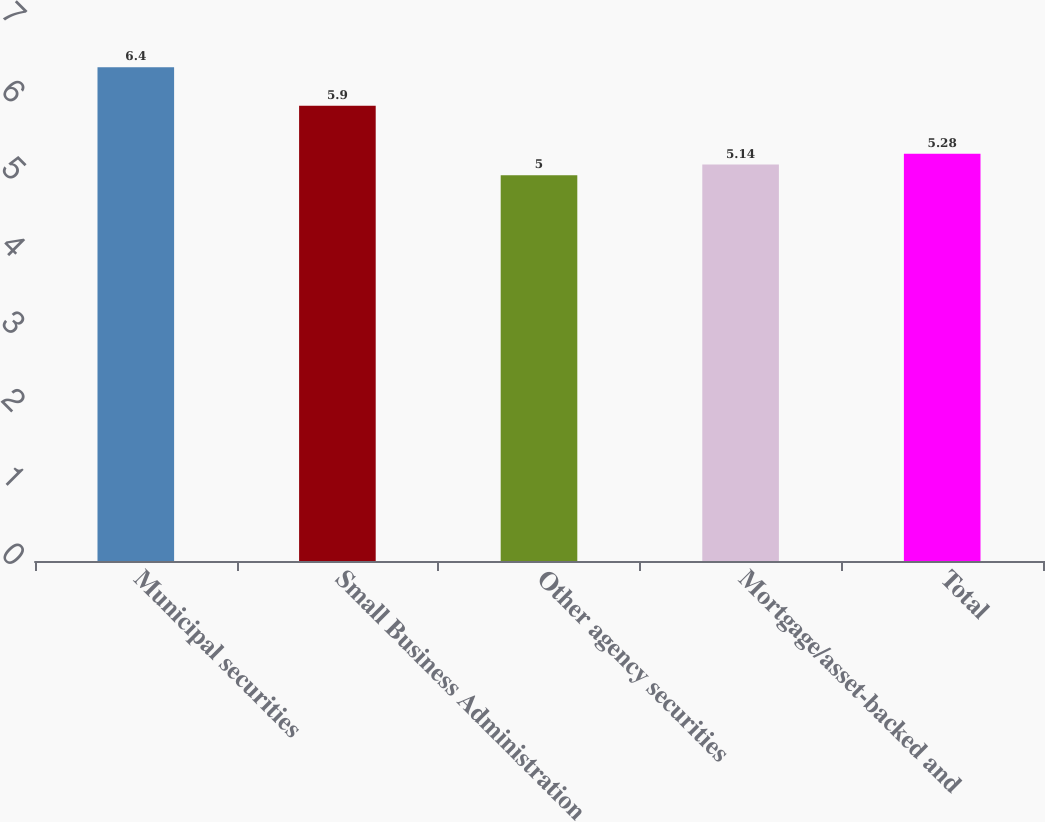<chart> <loc_0><loc_0><loc_500><loc_500><bar_chart><fcel>Municipal securities<fcel>Small Business Administration<fcel>Other agency securities<fcel>Mortgage/asset-backed and<fcel>Total<nl><fcel>6.4<fcel>5.9<fcel>5<fcel>5.14<fcel>5.28<nl></chart> 